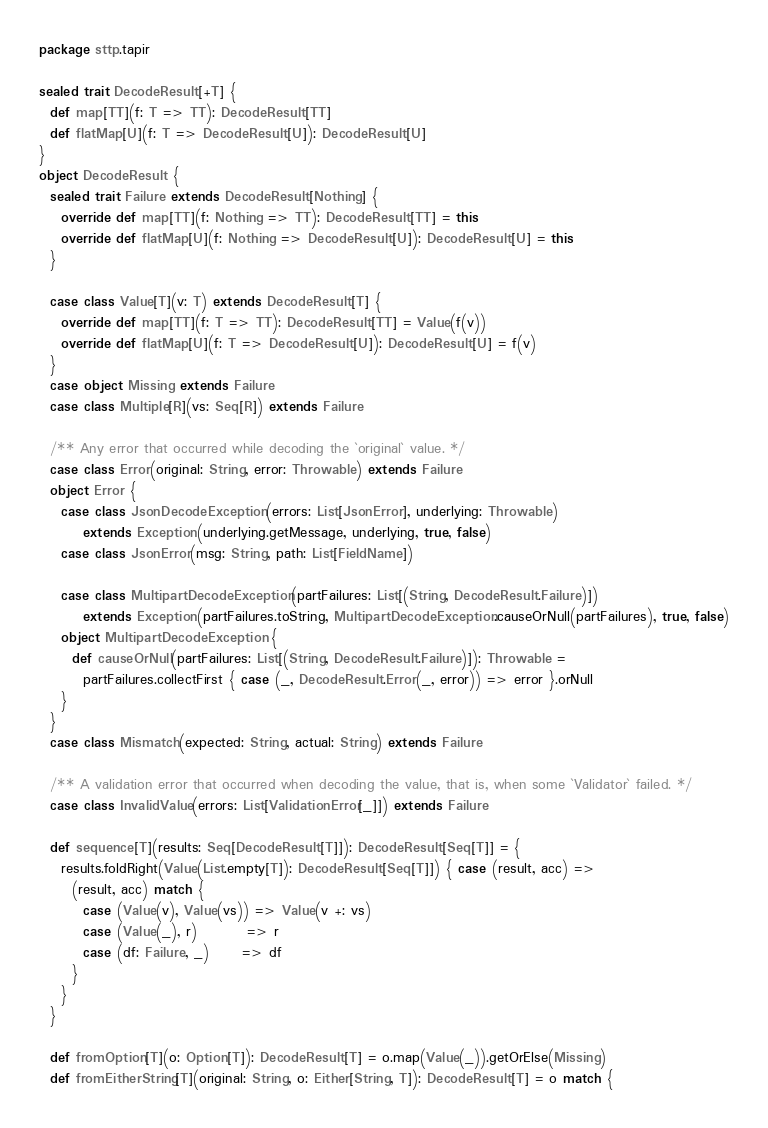<code> <loc_0><loc_0><loc_500><loc_500><_Scala_>package sttp.tapir

sealed trait DecodeResult[+T] {
  def map[TT](f: T => TT): DecodeResult[TT]
  def flatMap[U](f: T => DecodeResult[U]): DecodeResult[U]
}
object DecodeResult {
  sealed trait Failure extends DecodeResult[Nothing] {
    override def map[TT](f: Nothing => TT): DecodeResult[TT] = this
    override def flatMap[U](f: Nothing => DecodeResult[U]): DecodeResult[U] = this
  }

  case class Value[T](v: T) extends DecodeResult[T] {
    override def map[TT](f: T => TT): DecodeResult[TT] = Value(f(v))
    override def flatMap[U](f: T => DecodeResult[U]): DecodeResult[U] = f(v)
  }
  case object Missing extends Failure
  case class Multiple[R](vs: Seq[R]) extends Failure

  /** Any error that occurred while decoding the `original` value. */
  case class Error(original: String, error: Throwable) extends Failure
  object Error {
    case class JsonDecodeException(errors: List[JsonError], underlying: Throwable)
        extends Exception(underlying.getMessage, underlying, true, false)
    case class JsonError(msg: String, path: List[FieldName])

    case class MultipartDecodeException(partFailures: List[(String, DecodeResult.Failure)])
        extends Exception(partFailures.toString, MultipartDecodeException.causeOrNull(partFailures), true, false)
    object MultipartDecodeException {
      def causeOrNull(partFailures: List[(String, DecodeResult.Failure)]): Throwable =
        partFailures.collectFirst { case (_, DecodeResult.Error(_, error)) => error }.orNull
    }
  }
  case class Mismatch(expected: String, actual: String) extends Failure

  /** A validation error that occurred when decoding the value, that is, when some `Validator` failed. */
  case class InvalidValue(errors: List[ValidationError[_]]) extends Failure

  def sequence[T](results: Seq[DecodeResult[T]]): DecodeResult[Seq[T]] = {
    results.foldRight(Value(List.empty[T]): DecodeResult[Seq[T]]) { case (result, acc) =>
      (result, acc) match {
        case (Value(v), Value(vs)) => Value(v +: vs)
        case (Value(_), r)         => r
        case (df: Failure, _)      => df
      }
    }
  }

  def fromOption[T](o: Option[T]): DecodeResult[T] = o.map(Value(_)).getOrElse(Missing)
  def fromEitherString[T](original: String, o: Either[String, T]): DecodeResult[T] = o match {</code> 